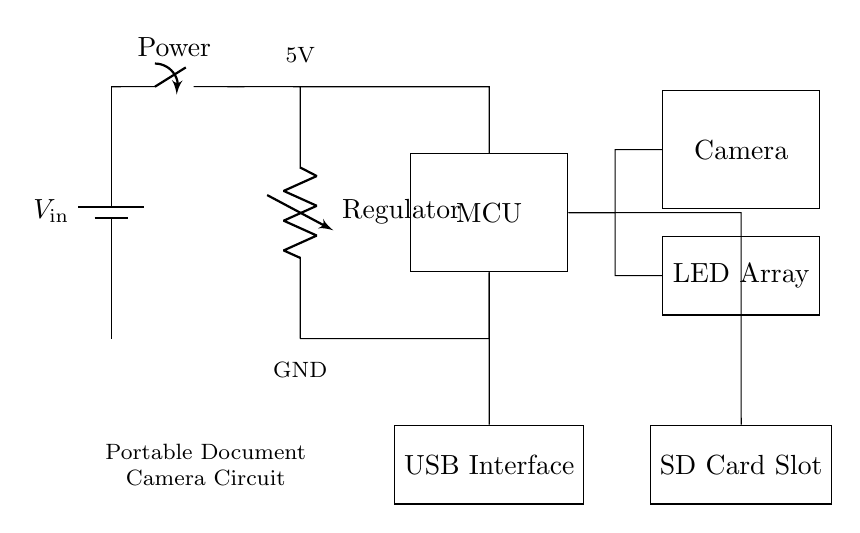What is the main component that controls the operations in this circuit? The main component is the microcontroller, which is represented as a rectangle labeled "MCU" in the circuit diagram. It connects to all other components to manage their functions.
Answer: MCU What is the purpose of the voltage regulator in this circuit? The voltage regulator ensures that the voltage supplied to the microcontroller and other components remains stable at 5V, which is crucial for proper operation.
Answer: Regulator How many main functional units are present in the circuit? There are four main functional units: the microcontroller, camera module, LED array, and USB interface. Each unit is represented as a block in the circuit.
Answer: Four What type of interface is used to connect this camera to other devices? The circuit includes a USB interface, which facilitates connection and data transfer between the portable document camera and external devices such as computers.
Answer: USB Interface What are the outputs connected to the microcontroller in this design? The outputs connected to the microcontroller are the camera module and LED array, both of which are vital for the camera's image capture and illumination.
Answer: Camera and LED Array What is the significance of the SD card slot present in the circuit? The SD card slot allows for external storage of captured images, enabling users to save and later retrieve their documents efficiently.
Answer: Storage At what voltage is this circuit designed to operate? The circuit is designed to operate at a voltage of 5 volts, indicated by the label next to the voltage regulator.
Answer: 5V 